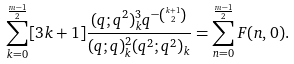Convert formula to latex. <formula><loc_0><loc_0><loc_500><loc_500>\sum _ { k = 0 } ^ { \frac { m - 1 } { 2 } } [ 3 k + 1 ] \frac { ( q ; q ^ { 2 } ) _ { k } ^ { 3 } q ^ { - { k + 1 \choose 2 } } } { ( q ; q ) _ { k } ^ { 2 } ( q ^ { 2 } ; q ^ { 2 } ) _ { k } } = \sum _ { n = 0 } ^ { \frac { m - 1 } { 2 } } F ( n , 0 ) .</formula> 